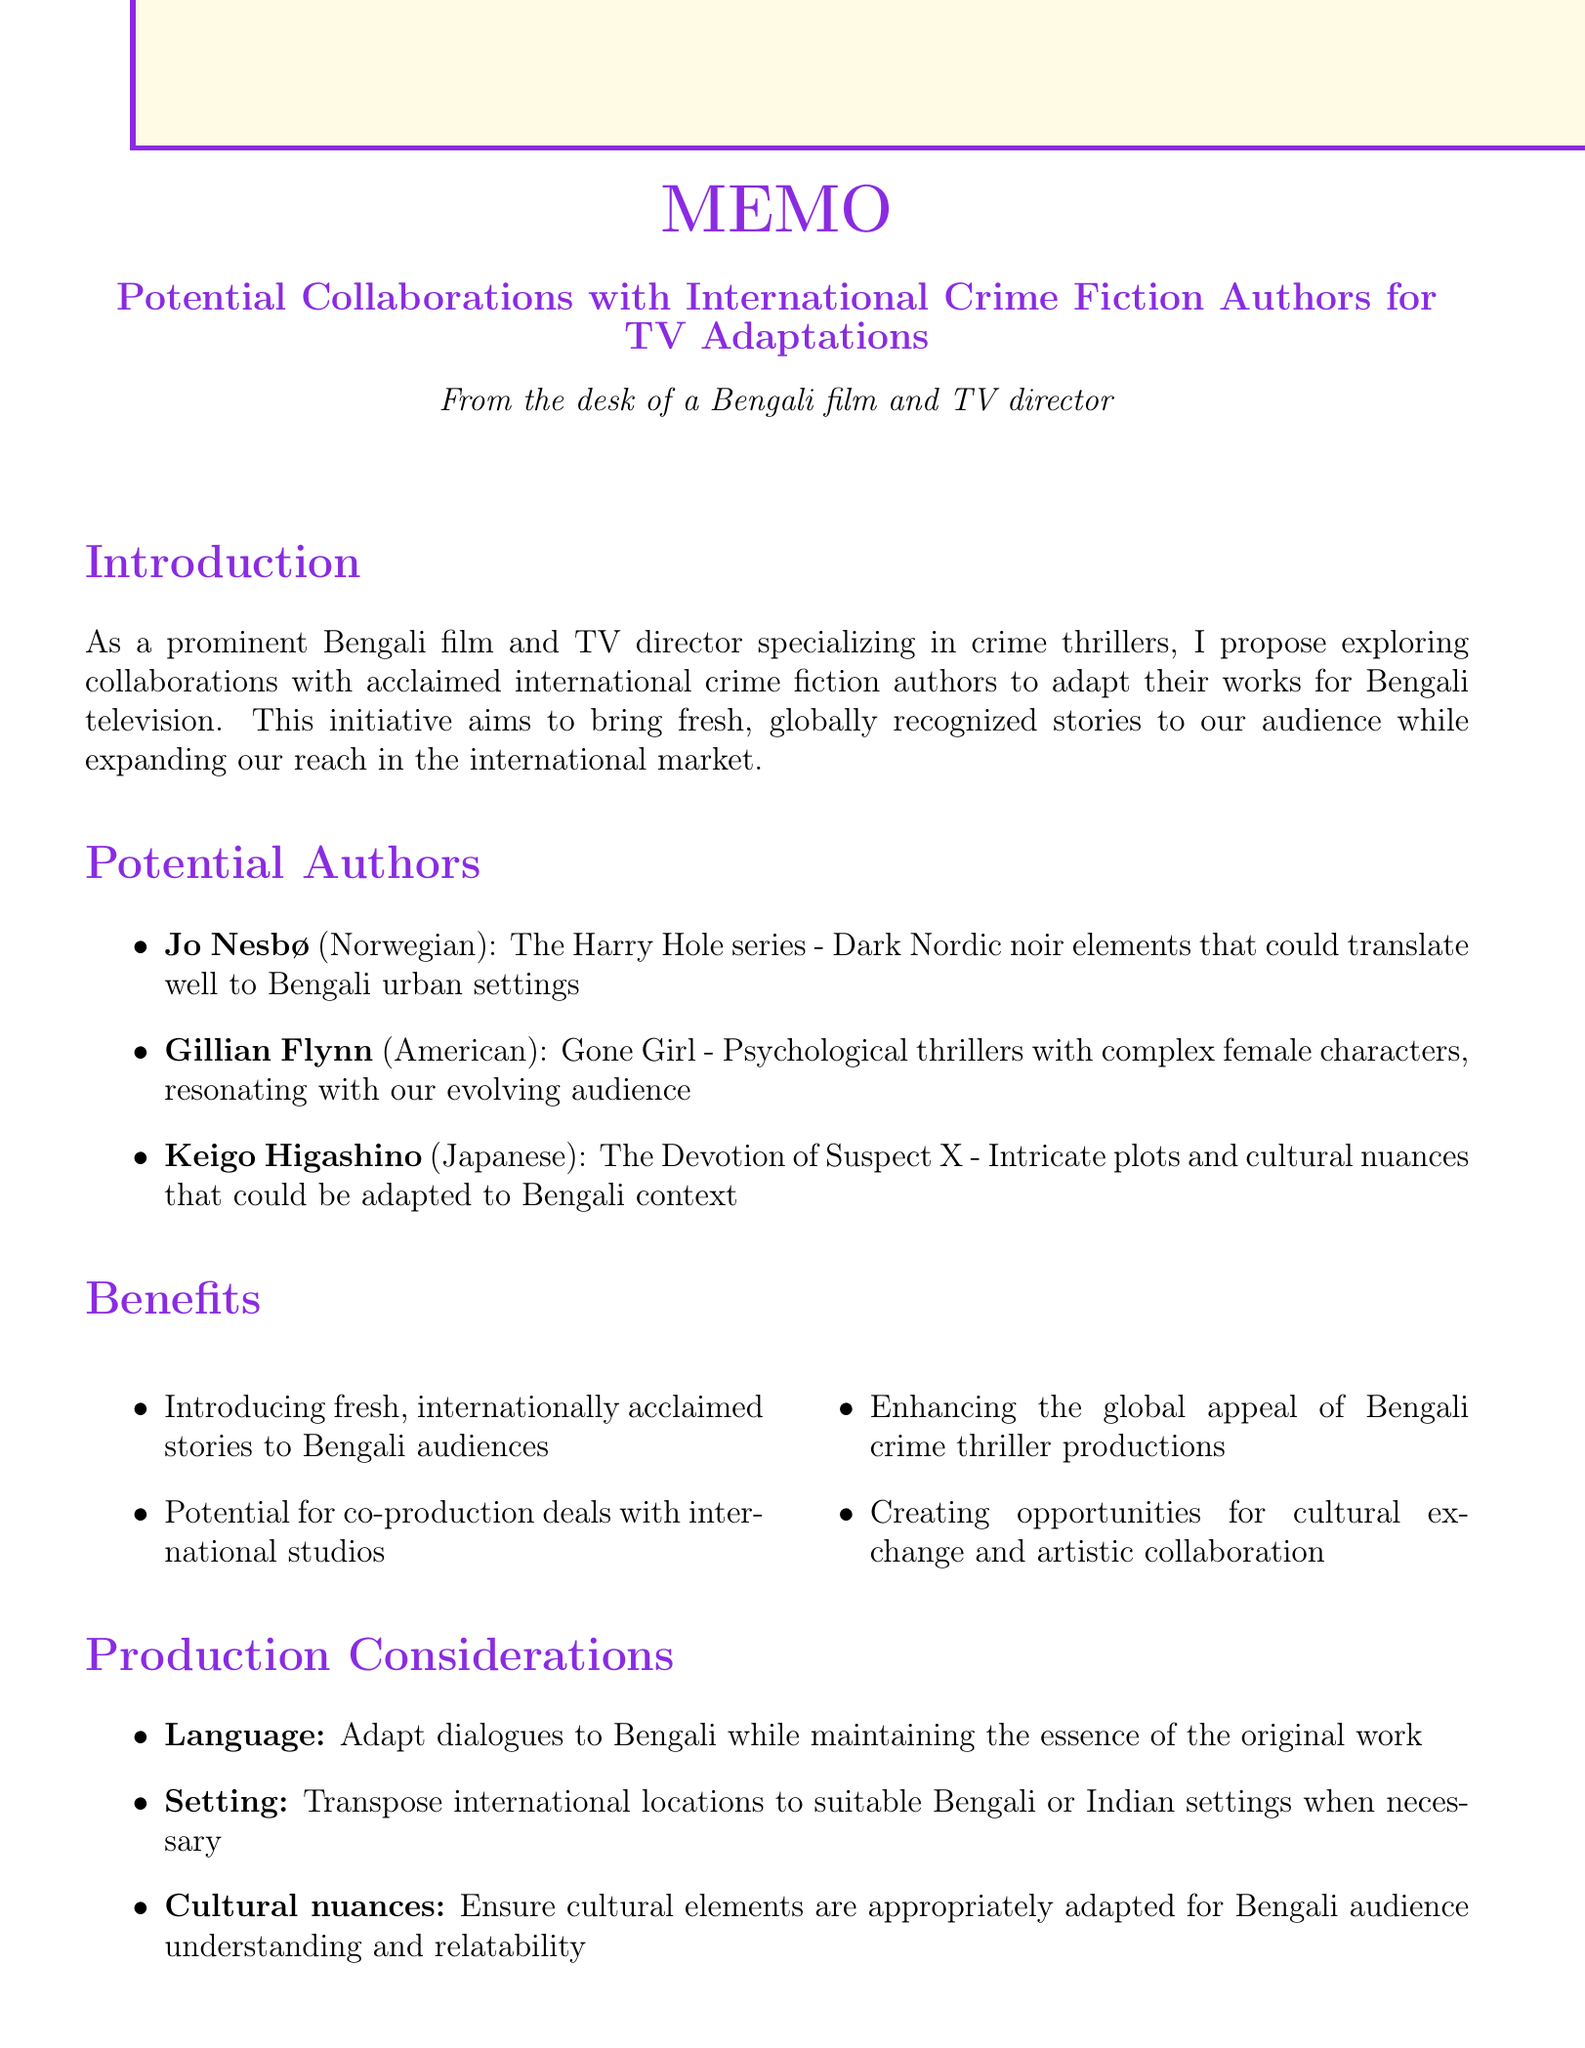What is the title of the memo? The title of the memo is presented prominently at the beginning.
Answer: Potential Collaborations with International Crime Fiction Authors for TV Adaptations Who is the author of "Gone Girl"? The memo lists notable works along with their authors.
Answer: Gillian Flynn What type of production partner is SVF Entertainment? The memo categorizes potential partners by type, indicating the nature of each partner.
Answer: Production company How many authors are identified for potential collaboration? The memo lists potential authors in a numbered format.
Answer: Three What are the next steps mentioned in the memo? The next steps are outlined as actionable items toward collaboration.
Answer: Reach out to literary agents representing the identified authors What is one of the benefits of collaborating with international authors? Benefits are listed to highlight the advantages of the proposed initiative.
Answer: Introducing fresh, internationally acclaimed stories to Bengali audiences What adaptation potential does Jo Nesbø's work hold? The memo outlines specific adaptation potentials for each author.
Answer: Dark Nordic noir elements that could translate well to Bengali urban settings What is the primary focus of the memo? The introduction provides a summary of the memo’s goal.
Answer: Collaborations with acclaimed international crime fiction authors 